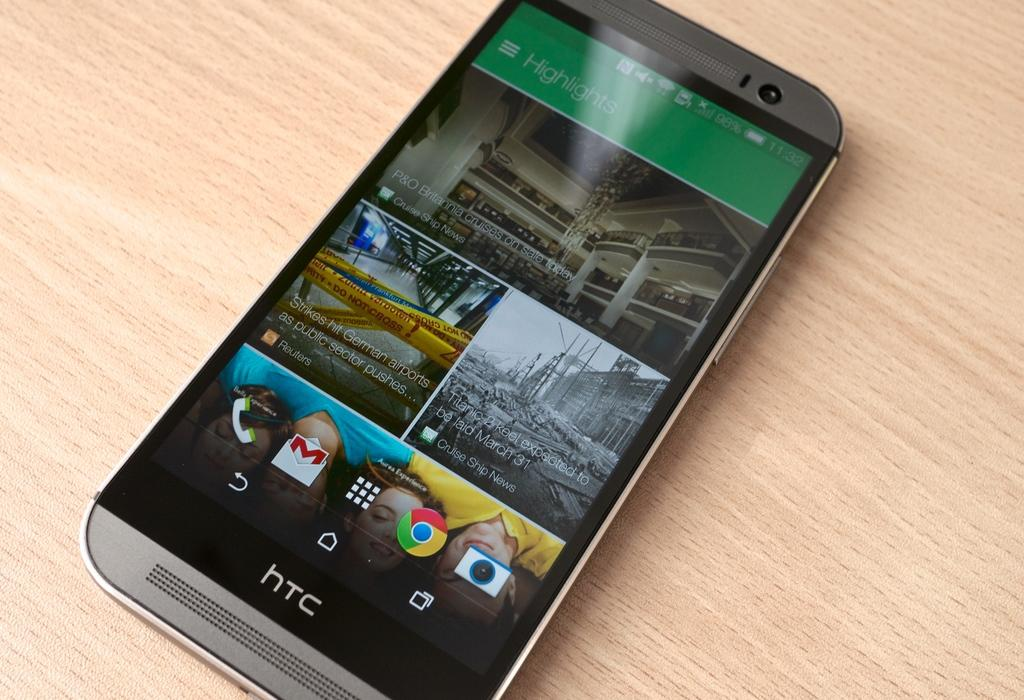What electronic device is present in the image? There is a mobile phone in the image. What is the mobile phone placed on? The mobile phone is on a wooden plank. What brand name is displayed on the mobile phone? The mobile phone has a brand name displayed on it. What can be seen on the mobile phone's screen? There are options visible on the mobile phone's screen. How many cars are parked on the wooden plank next to the mobile phone? There are no cars present in the image. The image only shows a 